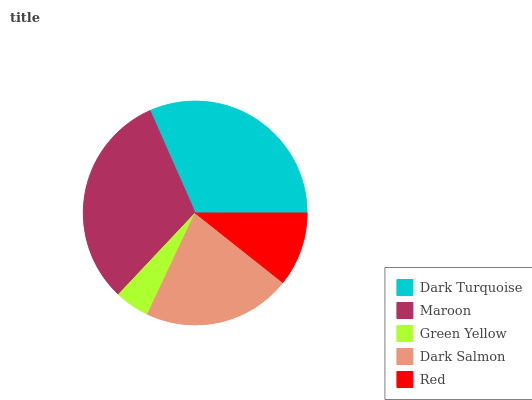Is Green Yellow the minimum?
Answer yes or no. Yes. Is Dark Turquoise the maximum?
Answer yes or no. Yes. Is Maroon the minimum?
Answer yes or no. No. Is Maroon the maximum?
Answer yes or no. No. Is Dark Turquoise greater than Maroon?
Answer yes or no. Yes. Is Maroon less than Dark Turquoise?
Answer yes or no. Yes. Is Maroon greater than Dark Turquoise?
Answer yes or no. No. Is Dark Turquoise less than Maroon?
Answer yes or no. No. Is Dark Salmon the high median?
Answer yes or no. Yes. Is Dark Salmon the low median?
Answer yes or no. Yes. Is Dark Turquoise the high median?
Answer yes or no. No. Is Red the low median?
Answer yes or no. No. 